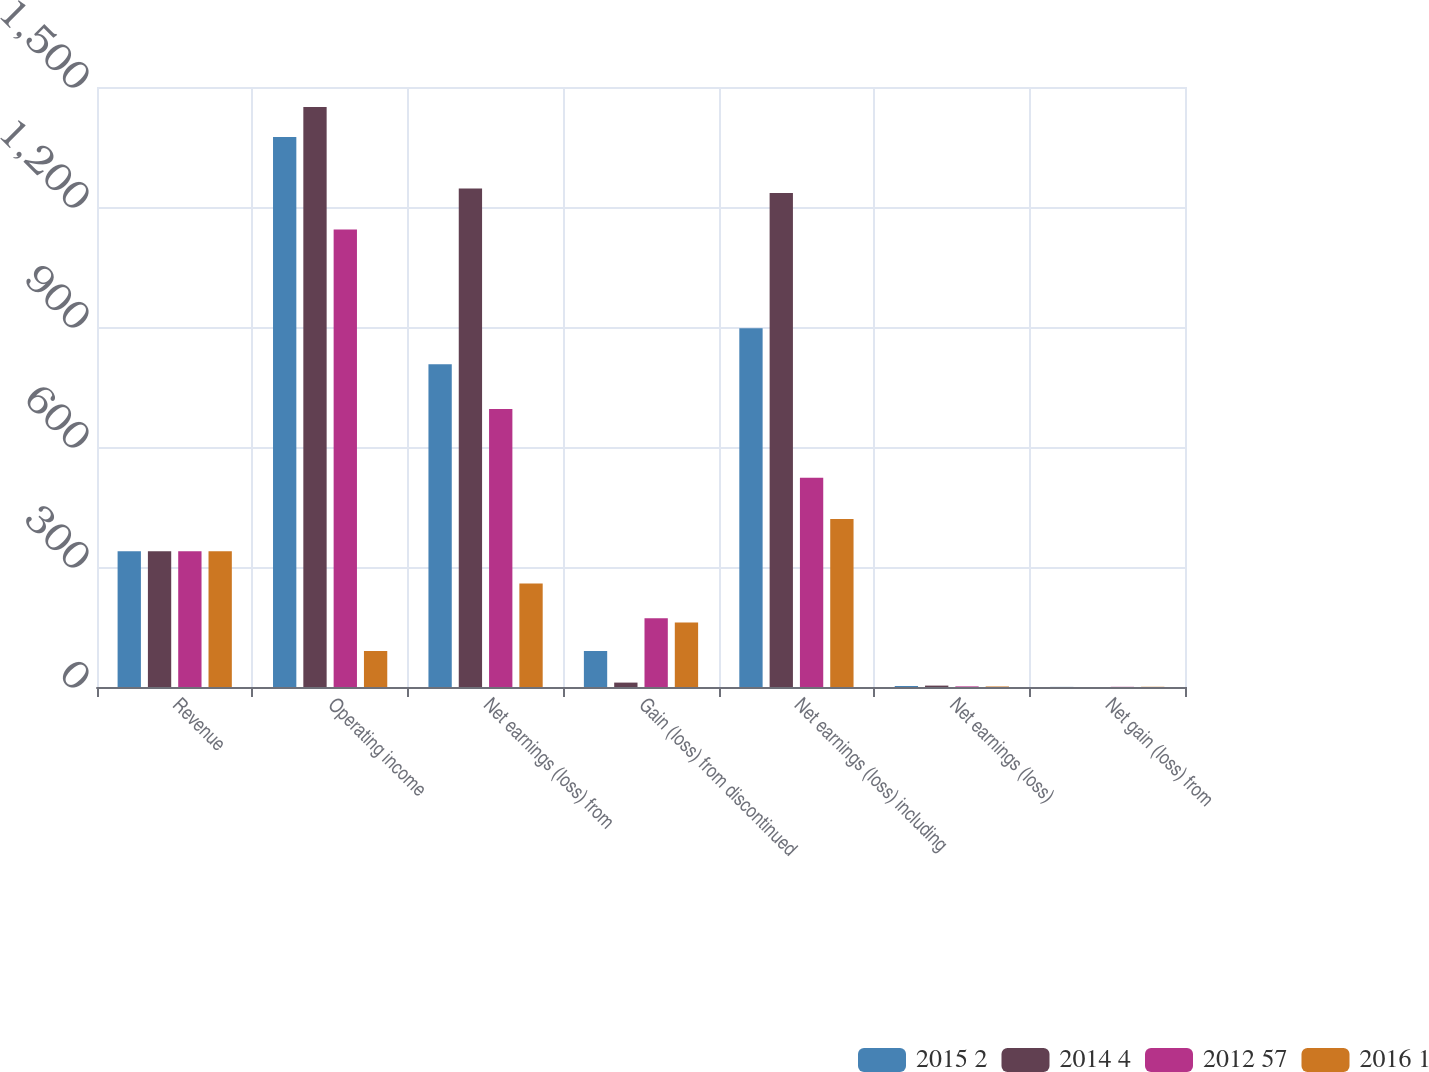Convert chart to OTSL. <chart><loc_0><loc_0><loc_500><loc_500><stacked_bar_chart><ecel><fcel>Revenue<fcel>Operating income<fcel>Net earnings (loss) from<fcel>Gain (loss) from discontinued<fcel>Net earnings (loss) including<fcel>Net earnings (loss)<fcel>Net gain (loss) from<nl><fcel>2015 2<fcel>339.5<fcel>1375<fcel>807<fcel>90<fcel>897<fcel>2.56<fcel>0.26<nl><fcel>2014 4<fcel>339.5<fcel>1450<fcel>1246<fcel>11<fcel>1235<fcel>3.49<fcel>0.04<nl><fcel>2012 57<fcel>339.5<fcel>1144<fcel>695<fcel>172<fcel>523<fcel>1.53<fcel>0.47<nl><fcel>2016 1<fcel>339.5<fcel>90<fcel>259<fcel>161<fcel>420<fcel>1.3<fcel>0.54<nl></chart> 